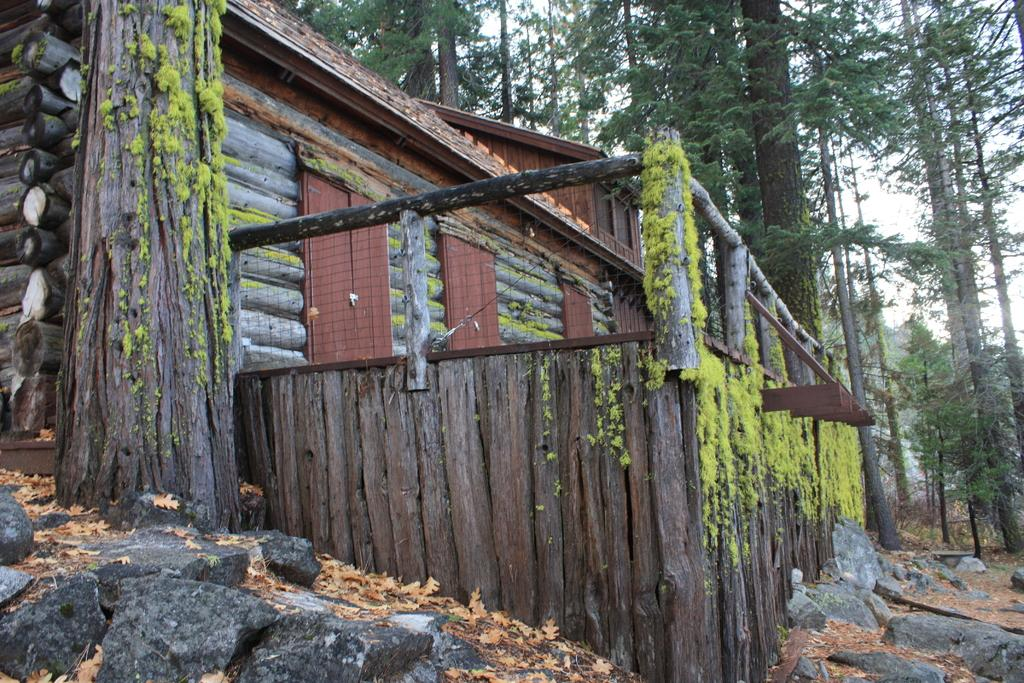What type of vegetation can be seen in the image? There are trees in the image. What other objects can be seen on the ground in the image? There are stones and dry leaves visible in the image. What type of structure is present in the image? There is a wooden log house in the image. What architectural features can be seen in the image? There are doors and fencing in the image. What is the color of the sky in the image? The sky appears to be white in color. What type of honey can be seen dripping from the trees in the image? There is no honey present in the image; it features trees, stones, dry leaves, a wooden log house, doors, fencing, and a white sky. What type of drug is being used by the person in the image? There is no person or drug present in the image. 